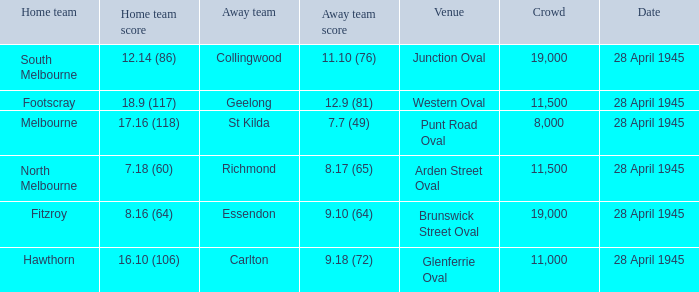Which home team has an Away team of essendon? 8.16 (64). 